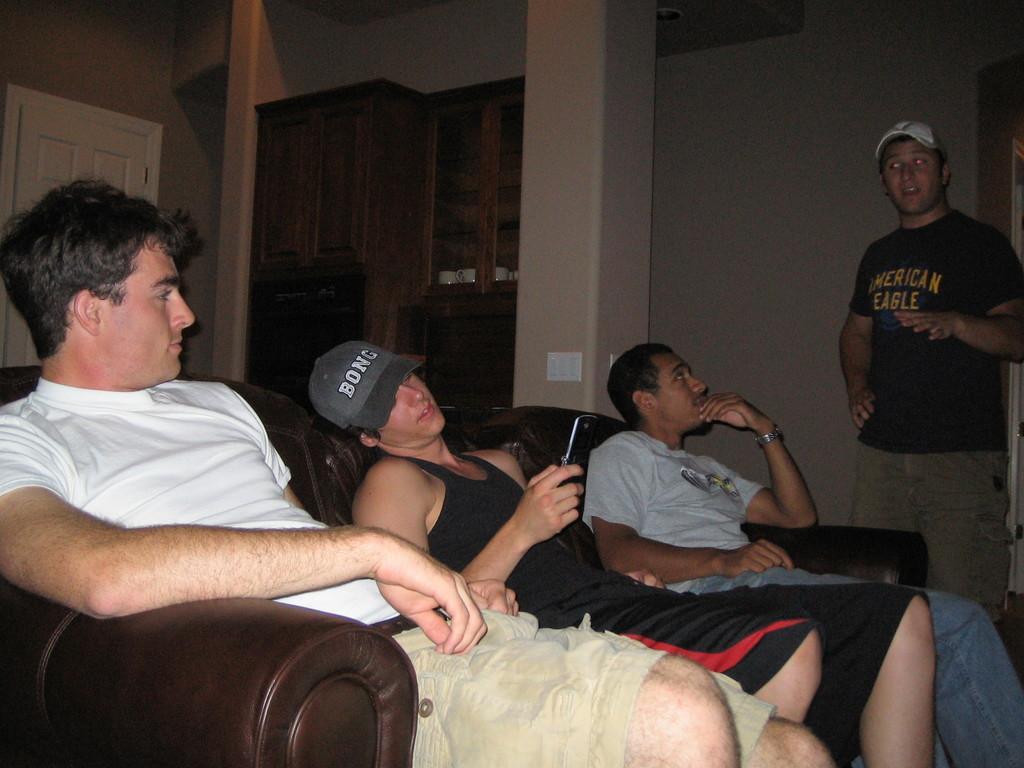Could you give a brief overview of what you see in this image? In this image I can see three persons sitting on the couch and the couch is in brown color. The person in front wearing white shirt, brown short. I can also see the other person standing wearing brown shirt and black shirt. Background I can see few cupboards in brown color and the is wall in cream color. 